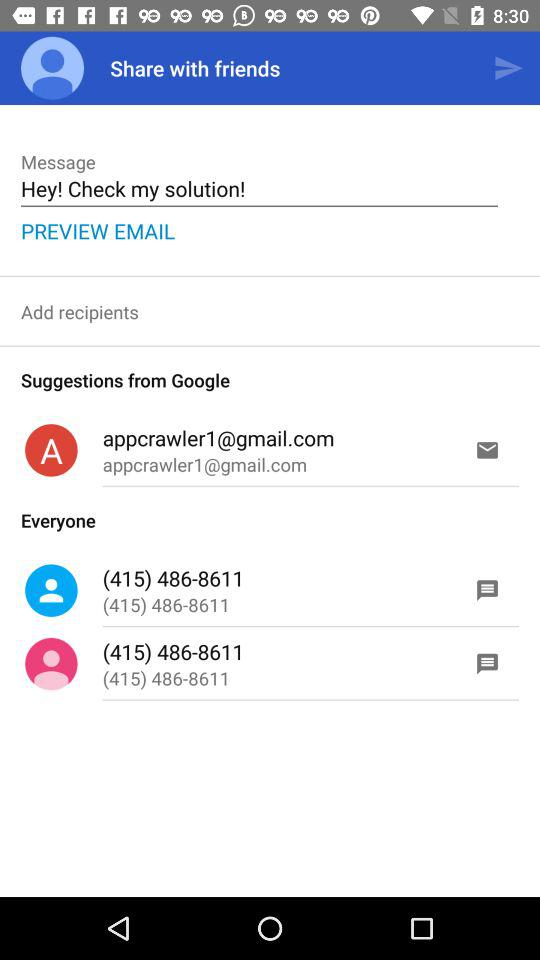What is the written message? The written message is "Hey! Check my solution!". 